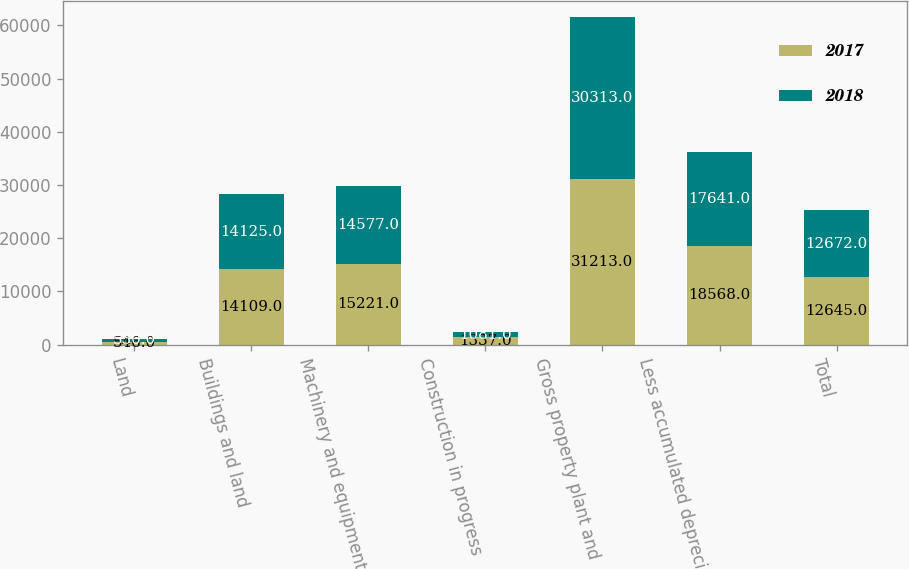Convert chart to OTSL. <chart><loc_0><loc_0><loc_500><loc_500><stacked_bar_chart><ecel><fcel>Land<fcel>Buildings and land<fcel>Machinery and equipment<fcel>Construction in progress<fcel>Gross property plant and<fcel>Less accumulated depreciation<fcel>Total<nl><fcel>2017<fcel>546<fcel>14109<fcel>15221<fcel>1337<fcel>31213<fcel>18568<fcel>12645<nl><fcel>2018<fcel>530<fcel>14125<fcel>14577<fcel>1081<fcel>30313<fcel>17641<fcel>12672<nl></chart> 